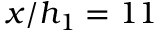<formula> <loc_0><loc_0><loc_500><loc_500>x / h _ { 1 } = 1 1</formula> 